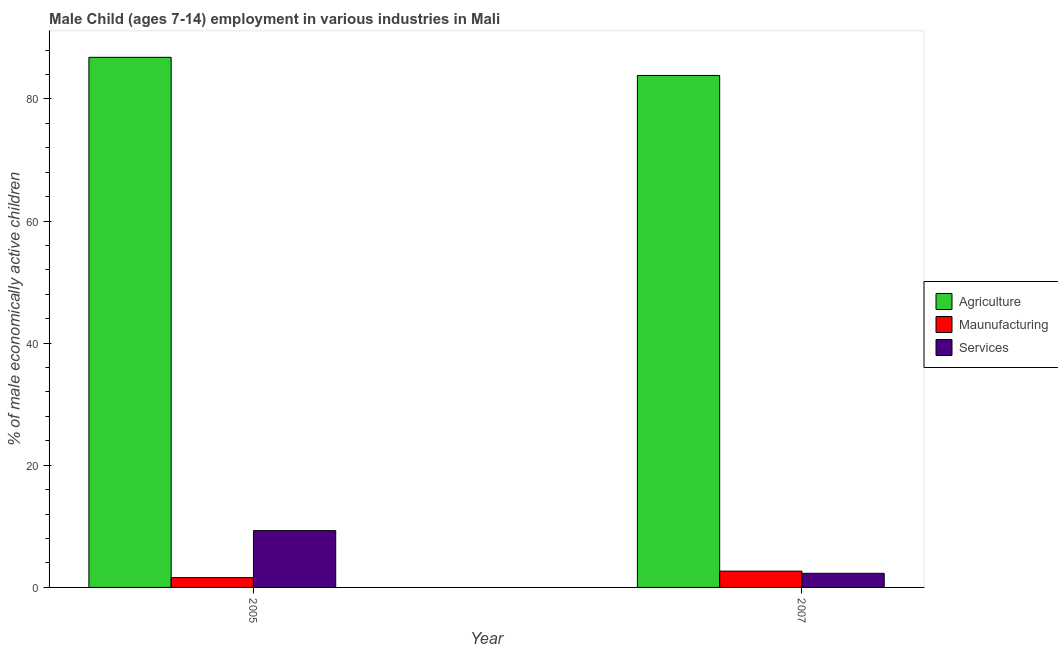How many different coloured bars are there?
Offer a very short reply. 3. How many groups of bars are there?
Your response must be concise. 2. Are the number of bars on each tick of the X-axis equal?
Offer a terse response. Yes. How many bars are there on the 2nd tick from the left?
Your answer should be compact. 3. How many bars are there on the 1st tick from the right?
Provide a short and direct response. 3. In how many cases, is the number of bars for a given year not equal to the number of legend labels?
Your response must be concise. 0. What is the percentage of economically active children in services in 2005?
Offer a terse response. 9.3. Across all years, what is the maximum percentage of economically active children in agriculture?
Provide a short and direct response. 86.8. Across all years, what is the minimum percentage of economically active children in agriculture?
Your response must be concise. 83.83. In which year was the percentage of economically active children in services minimum?
Your answer should be compact. 2007. What is the total percentage of economically active children in manufacturing in the graph?
Keep it short and to the point. 4.27. What is the difference between the percentage of economically active children in manufacturing in 2005 and that in 2007?
Offer a very short reply. -1.07. What is the difference between the percentage of economically active children in agriculture in 2007 and the percentage of economically active children in services in 2005?
Your answer should be compact. -2.97. What is the average percentage of economically active children in manufacturing per year?
Keep it short and to the point. 2.13. In the year 2007, what is the difference between the percentage of economically active children in agriculture and percentage of economically active children in services?
Your answer should be compact. 0. In how many years, is the percentage of economically active children in manufacturing greater than 48 %?
Your answer should be very brief. 0. What is the ratio of the percentage of economically active children in services in 2005 to that in 2007?
Your answer should be very brief. 4.03. In how many years, is the percentage of economically active children in manufacturing greater than the average percentage of economically active children in manufacturing taken over all years?
Offer a very short reply. 1. What does the 3rd bar from the left in 2007 represents?
Provide a succinct answer. Services. What does the 2nd bar from the right in 2007 represents?
Make the answer very short. Maunufacturing. Is it the case that in every year, the sum of the percentage of economically active children in agriculture and percentage of economically active children in manufacturing is greater than the percentage of economically active children in services?
Provide a succinct answer. Yes. What is the difference between two consecutive major ticks on the Y-axis?
Offer a very short reply. 20. Does the graph contain any zero values?
Keep it short and to the point. No. Does the graph contain grids?
Provide a succinct answer. No. Where does the legend appear in the graph?
Your response must be concise. Center right. How are the legend labels stacked?
Provide a succinct answer. Vertical. What is the title of the graph?
Provide a short and direct response. Male Child (ages 7-14) employment in various industries in Mali. What is the label or title of the X-axis?
Your answer should be very brief. Year. What is the label or title of the Y-axis?
Your answer should be very brief. % of male economically active children. What is the % of male economically active children in Agriculture in 2005?
Ensure brevity in your answer.  86.8. What is the % of male economically active children of Services in 2005?
Make the answer very short. 9.3. What is the % of male economically active children of Agriculture in 2007?
Make the answer very short. 83.83. What is the % of male economically active children in Maunufacturing in 2007?
Your response must be concise. 2.67. What is the % of male economically active children in Services in 2007?
Your response must be concise. 2.31. Across all years, what is the maximum % of male economically active children of Agriculture?
Make the answer very short. 86.8. Across all years, what is the maximum % of male economically active children of Maunufacturing?
Your answer should be very brief. 2.67. Across all years, what is the minimum % of male economically active children of Agriculture?
Make the answer very short. 83.83. Across all years, what is the minimum % of male economically active children in Services?
Offer a very short reply. 2.31. What is the total % of male economically active children in Agriculture in the graph?
Offer a very short reply. 170.63. What is the total % of male economically active children in Maunufacturing in the graph?
Provide a short and direct response. 4.27. What is the total % of male economically active children in Services in the graph?
Offer a very short reply. 11.61. What is the difference between the % of male economically active children of Agriculture in 2005 and that in 2007?
Provide a succinct answer. 2.97. What is the difference between the % of male economically active children in Maunufacturing in 2005 and that in 2007?
Keep it short and to the point. -1.07. What is the difference between the % of male economically active children of Services in 2005 and that in 2007?
Make the answer very short. 6.99. What is the difference between the % of male economically active children in Agriculture in 2005 and the % of male economically active children in Maunufacturing in 2007?
Give a very brief answer. 84.13. What is the difference between the % of male economically active children in Agriculture in 2005 and the % of male economically active children in Services in 2007?
Give a very brief answer. 84.49. What is the difference between the % of male economically active children of Maunufacturing in 2005 and the % of male economically active children of Services in 2007?
Provide a succinct answer. -0.71. What is the average % of male economically active children in Agriculture per year?
Offer a terse response. 85.31. What is the average % of male economically active children of Maunufacturing per year?
Your answer should be compact. 2.13. What is the average % of male economically active children in Services per year?
Make the answer very short. 5.8. In the year 2005, what is the difference between the % of male economically active children in Agriculture and % of male economically active children in Maunufacturing?
Provide a succinct answer. 85.2. In the year 2005, what is the difference between the % of male economically active children in Agriculture and % of male economically active children in Services?
Make the answer very short. 77.5. In the year 2005, what is the difference between the % of male economically active children of Maunufacturing and % of male economically active children of Services?
Provide a succinct answer. -7.7. In the year 2007, what is the difference between the % of male economically active children in Agriculture and % of male economically active children in Maunufacturing?
Provide a succinct answer. 81.16. In the year 2007, what is the difference between the % of male economically active children of Agriculture and % of male economically active children of Services?
Your answer should be very brief. 81.52. In the year 2007, what is the difference between the % of male economically active children of Maunufacturing and % of male economically active children of Services?
Your answer should be compact. 0.36. What is the ratio of the % of male economically active children in Agriculture in 2005 to that in 2007?
Ensure brevity in your answer.  1.04. What is the ratio of the % of male economically active children of Maunufacturing in 2005 to that in 2007?
Ensure brevity in your answer.  0.6. What is the ratio of the % of male economically active children in Services in 2005 to that in 2007?
Offer a very short reply. 4.03. What is the difference between the highest and the second highest % of male economically active children in Agriculture?
Give a very brief answer. 2.97. What is the difference between the highest and the second highest % of male economically active children of Maunufacturing?
Your answer should be very brief. 1.07. What is the difference between the highest and the second highest % of male economically active children in Services?
Offer a terse response. 6.99. What is the difference between the highest and the lowest % of male economically active children in Agriculture?
Provide a succinct answer. 2.97. What is the difference between the highest and the lowest % of male economically active children of Maunufacturing?
Provide a succinct answer. 1.07. What is the difference between the highest and the lowest % of male economically active children of Services?
Make the answer very short. 6.99. 